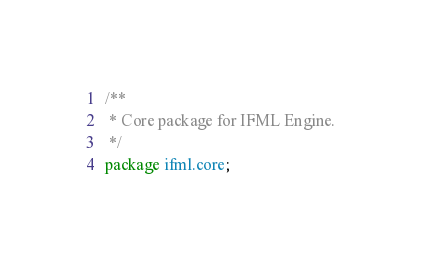<code> <loc_0><loc_0><loc_500><loc_500><_Java_>/**
 * Core package for IFML Engine.
 */
package ifml.core;
</code> 